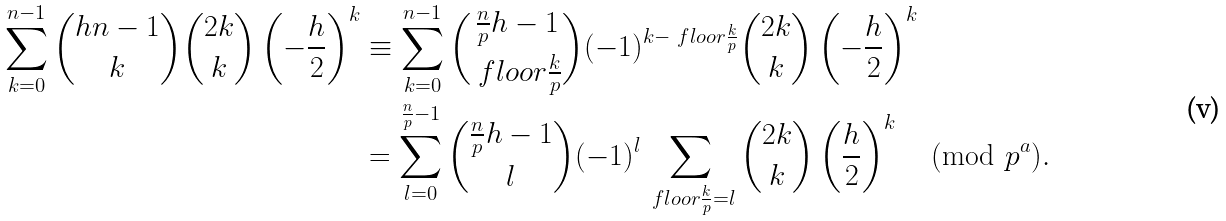<formula> <loc_0><loc_0><loc_500><loc_500>\sum _ { k = 0 } ^ { n - 1 } \binom { h n - 1 } { k } \binom { 2 k } { k } \left ( - \frac { h } { 2 } \right ) ^ { k } & \equiv \sum _ { k = 0 } ^ { n - 1 } \binom { \frac { n } { p } h - 1 } { \ f l o o r { \frac { k } { p } } } ( - 1 ) ^ { k - \ f l o o r { \frac { k } { p } } } \binom { 2 k } { k } \left ( - \frac { h } { 2 } \right ) ^ { k } \\ & = \sum _ { l = 0 } ^ { \frac { n } { p } - 1 } \binom { \frac { n } { p } h - 1 } { l } ( - 1 ) ^ { l } \sum _ { \ f l o o r { \frac { k } { p } } = l } \binom { 2 k } { k } \left ( \frac { h } { 2 } \right ) ^ { k } \pmod { p ^ { a } } .</formula> 